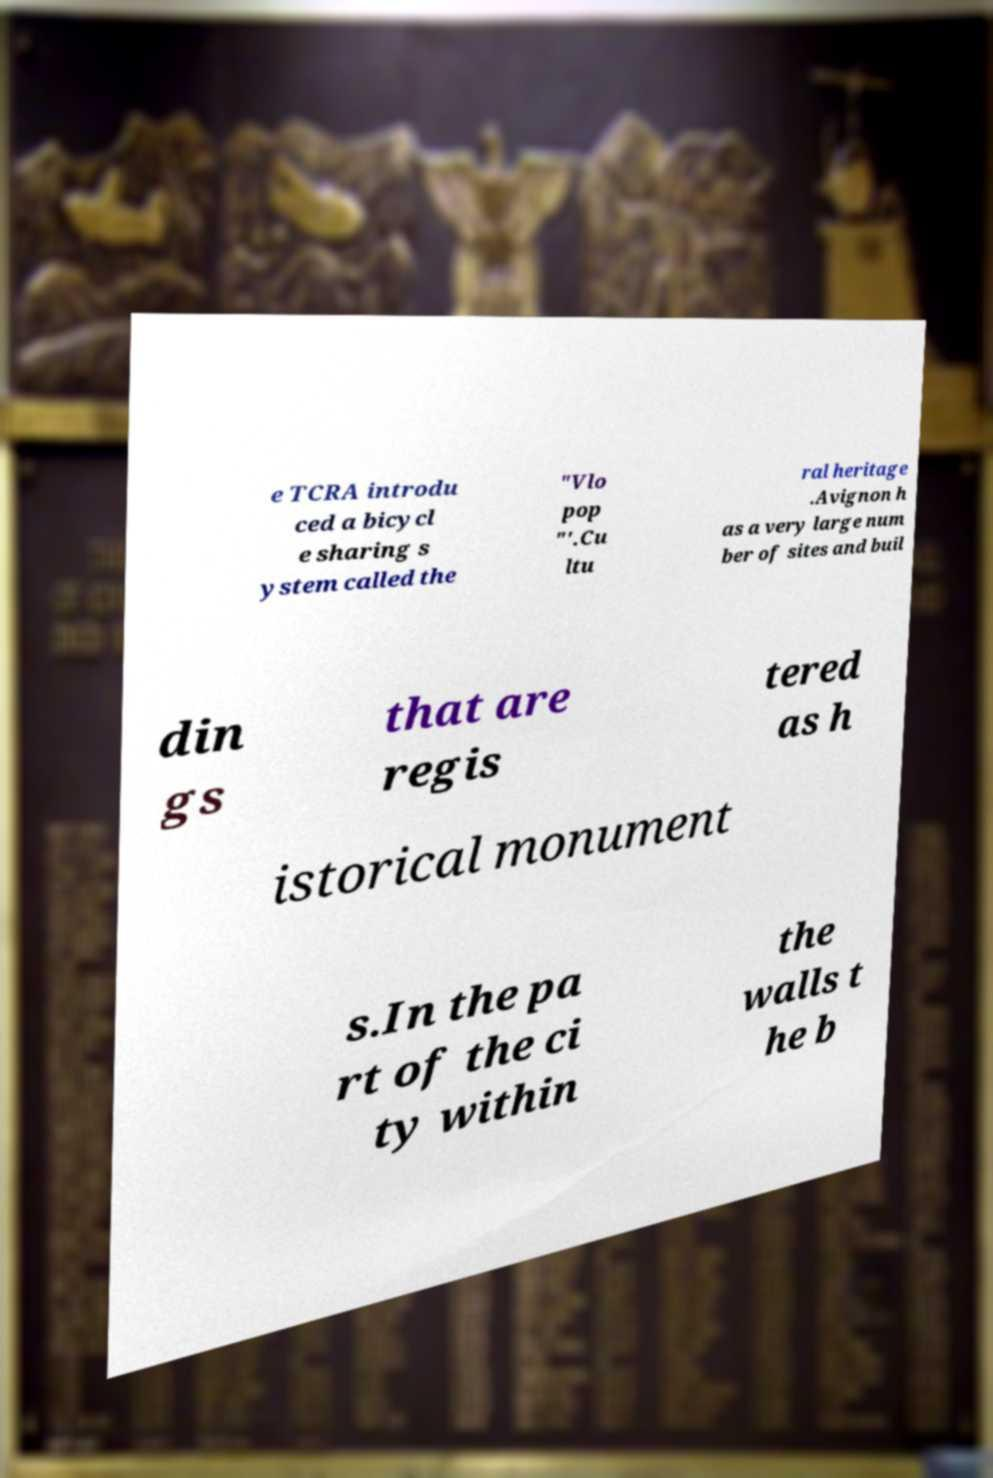For documentation purposes, I need the text within this image transcribed. Could you provide that? e TCRA introdu ced a bicycl e sharing s ystem called the "Vlo pop "'.Cu ltu ral heritage .Avignon h as a very large num ber of sites and buil din gs that are regis tered as h istorical monument s.In the pa rt of the ci ty within the walls t he b 